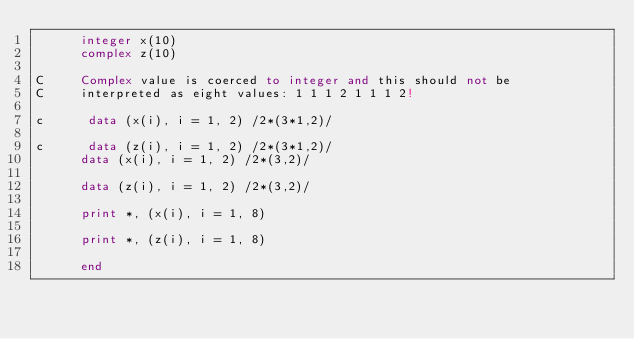<code> <loc_0><loc_0><loc_500><loc_500><_FORTRAN_>      integer x(10)
      complex z(10)

C     Complex value is coerced to integer and this should not be
C     interpreted as eight values: 1 1 1 2 1 1 1 2!

c      data (x(i), i = 1, 2) /2*(3*1,2)/

c      data (z(i), i = 1, 2) /2*(3*1,2)/
      data (x(i), i = 1, 2) /2*(3,2)/

      data (z(i), i = 1, 2) /2*(3,2)/

      print *, (x(i), i = 1, 8)

      print *, (z(i), i = 1, 8)

      end
</code> 